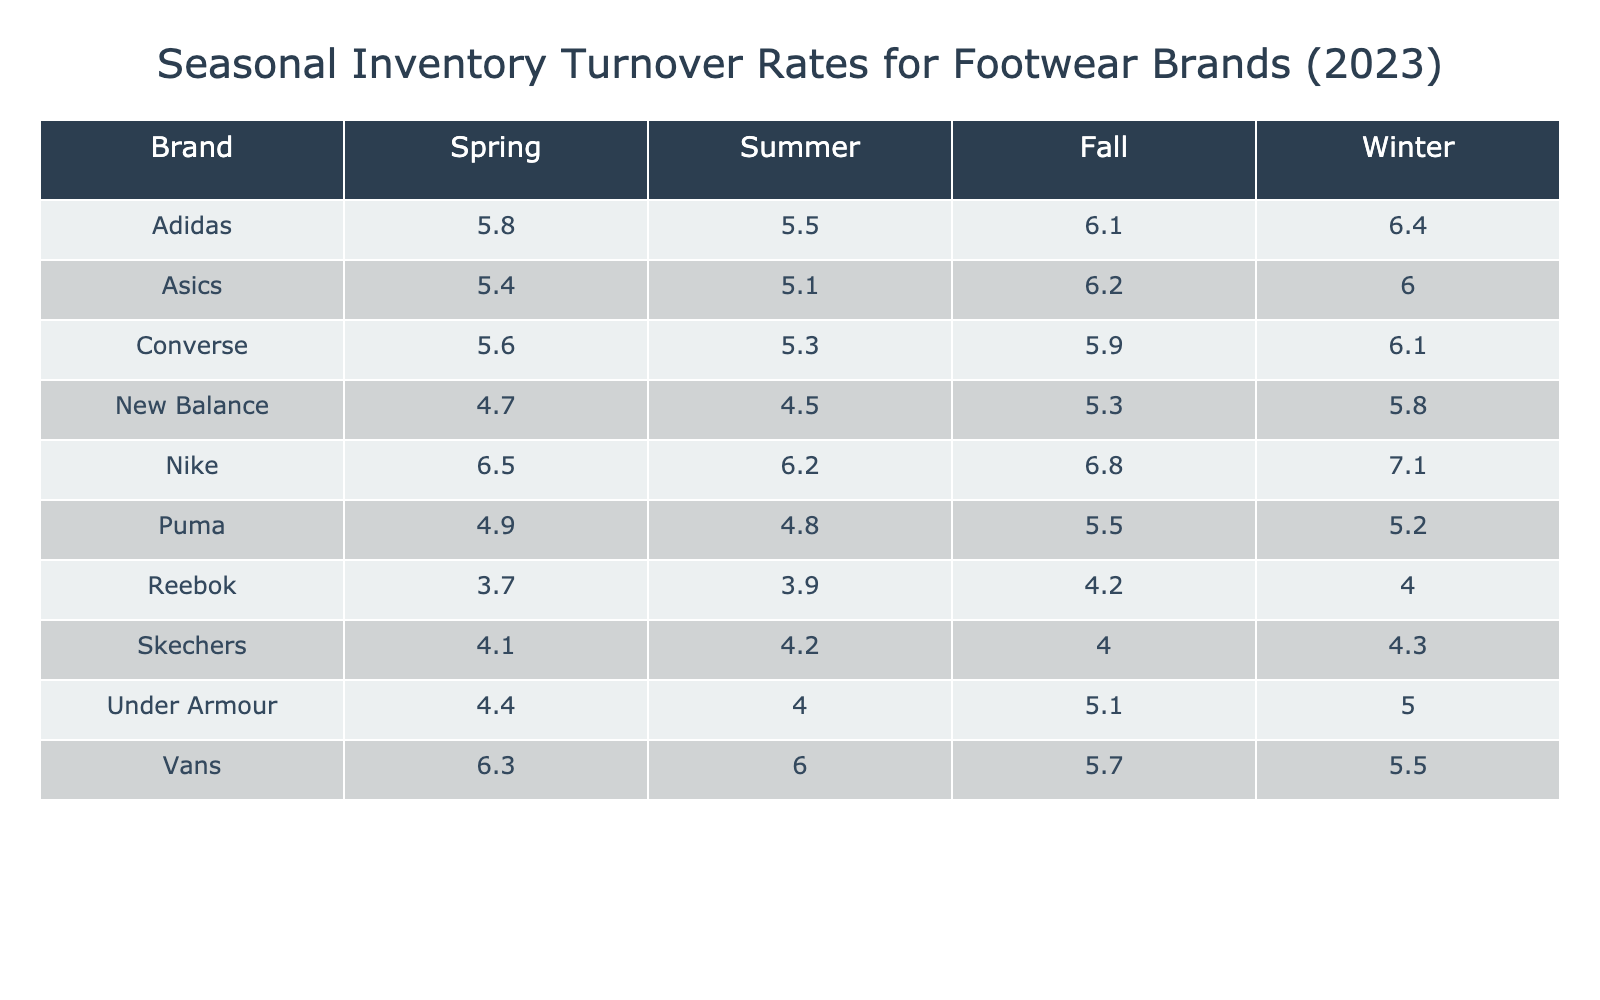What is the highest inventory turnover rate for Nike? The turnover rate for Nike in Winter is 7.1, which is the highest among all seasons for this brand.
Answer: 7.1 Which brand has the lowest inventory turnover rate in Fall? In Fall, Reebok has the lowest turnover rate of 4.2.
Answer: Reebok What is the average inventory turnover rate for Adidas across all seasons? The turnover rates for Adidas are 5.5 (Summer), 6.4 (Winter), 5.8 (Spring), and 6.1 (Fall). Adding these gives 5.5 + 6.4 + 5.8 + 6.1 = 23.8, and dividing by 4 gives an average of 23.8 / 4 = 5.95.
Answer: 5.95 Is the inventory turnover rate for Converse higher in Summer or Fall? Converse has a turnover rate of 5.3 in Summer and 5.9 in Fall. Since 5.9 is greater than 5.3, Converse has a higher turnover rate in Fall.
Answer: Yes Which brand has a consistent inventory turnover rate across all seasons? By examining the table, there is no brand that has the same turnover rate in all four seasons. Each brand varies their performance.
Answer: No What is the difference in inventory turnover rates between Spring and Winter for Puma? The turnover rate for Puma in Spring is 4.9, while in Winter it is 5.2. Thus, the difference is 5.2 - 4.9 = 0.3.
Answer: 0.3 Which season has the highest average inventory turnover rate across all brands? The seasonal turnover rates for all brands should be summed and divided by the number of brands for each season: Summer (6.2 + 5.5 + 4.8 + 3.9 + 4.5 + 5.1 + 4.0 + 6.0 + 4.2 + 5.3 = 56.5 / 10 = 5.65), Winter (7.1 + 6.4 + 5.2 + 4.0 + 5.8 + 6.0 + 5.0 + 5.5 + 4.3 + 6.1 = 56.2 / 10 = 5.62), Spring (6.5 + 5.8 + 4.9 + 3.7 + 4.7 + 5.4 + 4.4 + 6.3 + 4.1 + 5.6 = 56.0 / 10 = 5.60), Fall (6.8 + 6.1 + 5.5 + 4.2 + 5.3 + 6.2 + 5.1 + 5.7 + 4.0 + 5.9 = 58.8 / 10 = 5.88). Fall has the highest average.
Answer: Fall What is the combined inventory turnover rate for Vans in Summer and Winter? In Summer, Vans has a turnover rate of 6.0, and in Winter, it is 5.5. The combined total is 6.0 + 5.5 = 11.5.
Answer: 11.5 How does Under Armour’s inventory turnover rate in Spring compare to its rate in Summer? Under Armour has a turnover rate of 4.4 in Spring and 4.0 in Summer. Since 4.4 is greater than 4.0, Under Armour performs better in Spring.
Answer: Spring performs better 